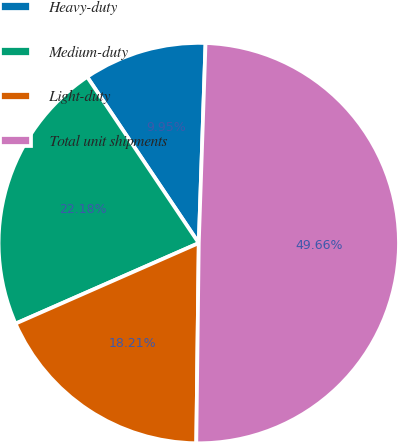Convert chart to OTSL. <chart><loc_0><loc_0><loc_500><loc_500><pie_chart><fcel>Heavy-duty<fcel>Medium-duty<fcel>Light-duty<fcel>Total unit shipments<nl><fcel>9.95%<fcel>22.18%<fcel>18.21%<fcel>49.66%<nl></chart> 